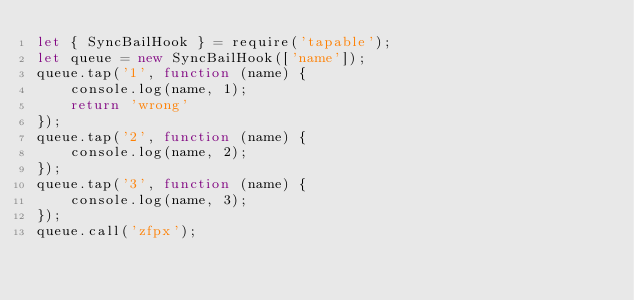Convert code to text. <code><loc_0><loc_0><loc_500><loc_500><_JavaScript_>let { SyncBailHook } = require('tapable');
let queue = new SyncBailHook(['name']);
queue.tap('1', function (name) {
    console.log(name, 1);
    return 'wrong'
});
queue.tap('2', function (name) {
    console.log(name, 2);
});
queue.tap('3', function (name) {
    console.log(name, 3);
});
queue.call('zfpx');</code> 